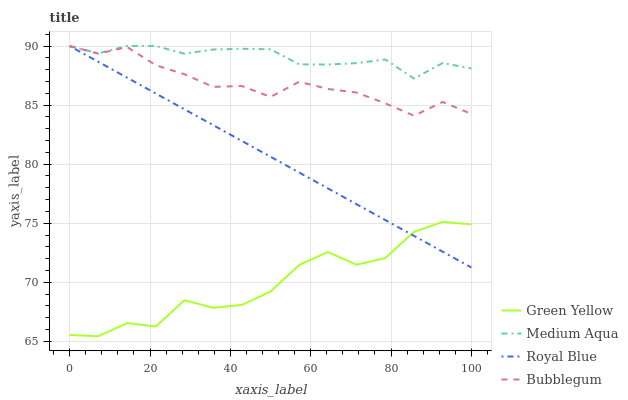Does Medium Aqua have the minimum area under the curve?
Answer yes or no. No. Does Green Yellow have the maximum area under the curve?
Answer yes or no. No. Is Medium Aqua the smoothest?
Answer yes or no. No. Is Medium Aqua the roughest?
Answer yes or no. No. Does Medium Aqua have the lowest value?
Answer yes or no. No. Does Green Yellow have the highest value?
Answer yes or no. No. Is Green Yellow less than Bubblegum?
Answer yes or no. Yes. Is Bubblegum greater than Green Yellow?
Answer yes or no. Yes. Does Green Yellow intersect Bubblegum?
Answer yes or no. No. 